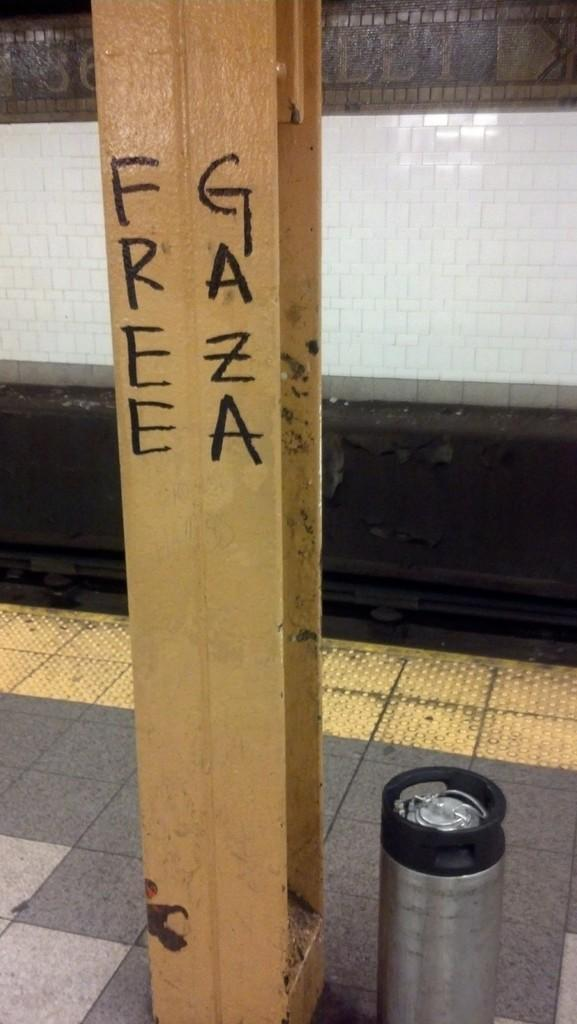<image>
Relay a brief, clear account of the picture shown. On a wooden post, the phrase "free Gaza" is written. 